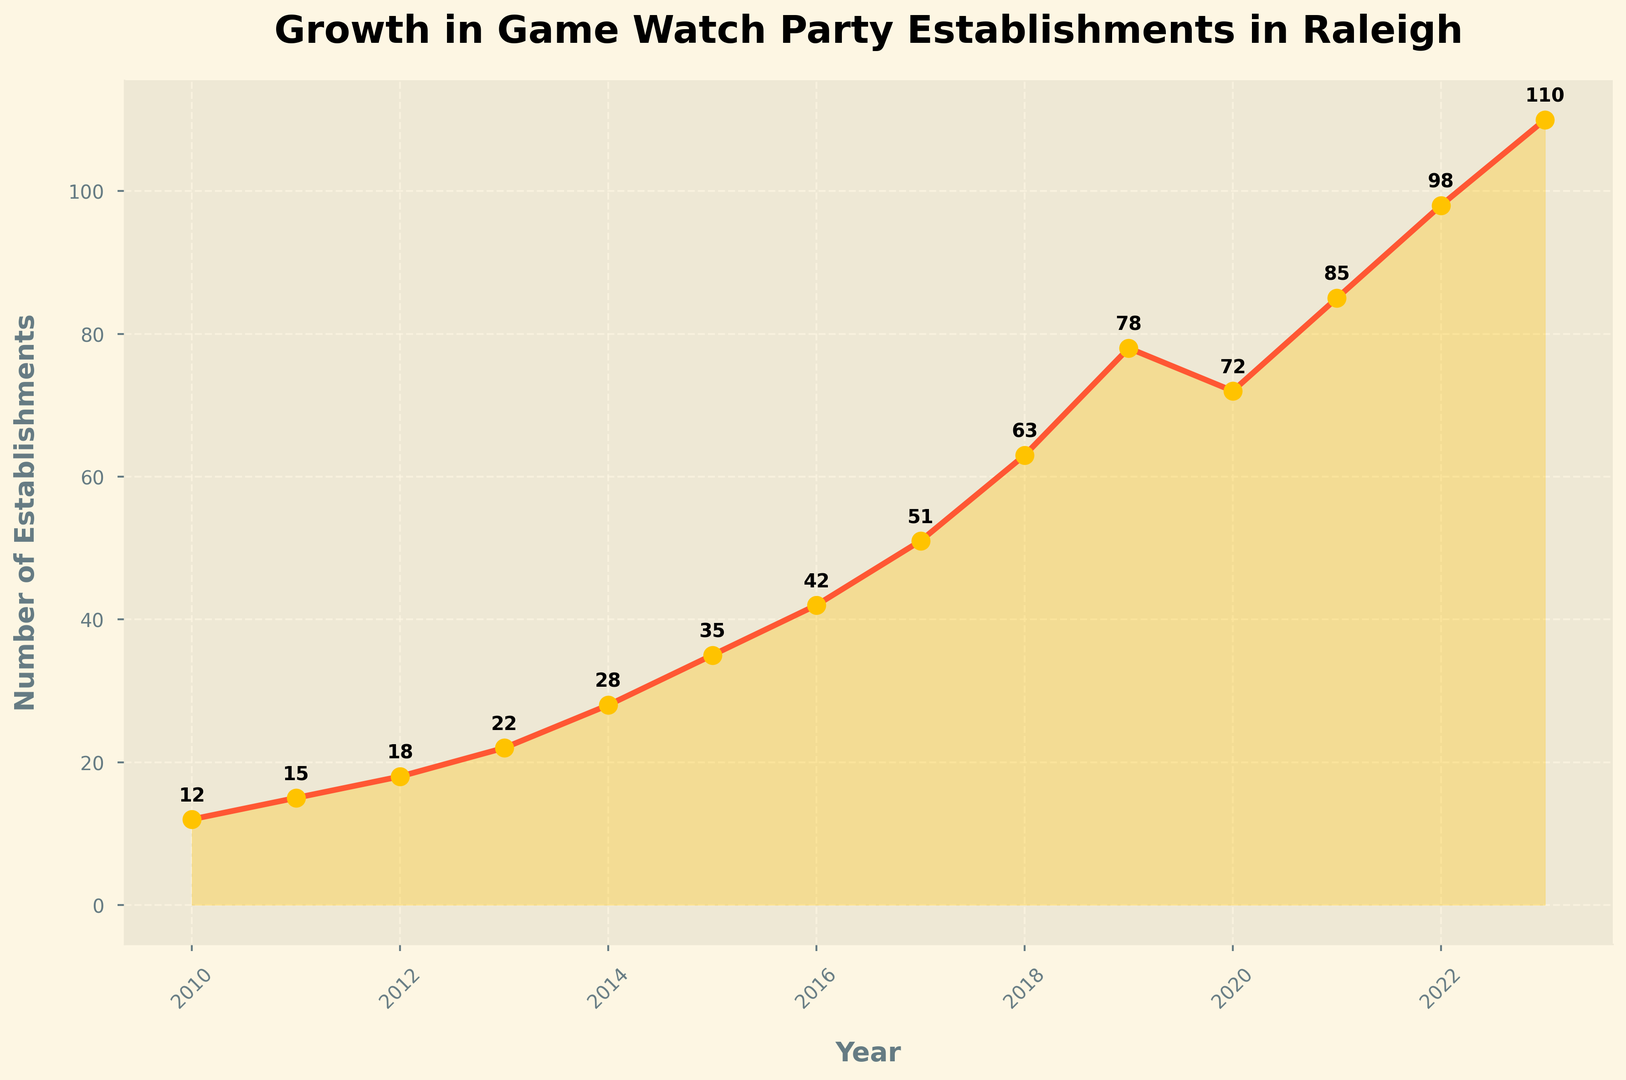What is the total number of establishments in 2015? The data points show the number of establishments in each year. By referring to the figure, find the point for 2015 and read its corresponding value on the y-axis.
Answer: 35 In which year did the number of establishments decrease compared to the previous year? Compare the number of establishments each year and identify any year where the number is lower than the previous year. In this case, between 2019 and 2020, the number decreased from 78 to 72.
Answer: 2020 What is the average number of establishments from 2018 to 2020? Sum the number of establishments from 2018 (63), 2019 (78), and 2020 (72), then divide by the number of years (3). The calculation is (63 + 78 + 72) / 3 = 213 / 3 = 71
Answer: 71 By how much did the number of establishments increase from 2010 to 2023? Subtract the number of establishments in 2010 (12) from the number in 2023 (110). The calculation is 110 - 12 = 98
Answer: 98 Which year saw the highest increase in the number of establishments compared to the previous year? Compare the year-over-year changes in the number of establishments. Between 2018 and 2019, the increase was the highest, going from 63 to 78, which is an increase of 15 establishments.
Answer: 2019 How many years show a number of establishments higher than 50? Look at the number of establishments for each year and count how many years have values greater than 50. From the figure, those years are 2017, 2018, 2019, 2020, 2021, 2022, and 2023. There are 7 years in total.
Answer: 7 What is the average growth in the number of establishments each year from 2011 to 2023? Find the total growth between 2011 (15 establishments) and 2023 (110 establishments). The calculation is 110 - 15 = 95. Then, divide by the number of years from 2011 to 2023, which is 12 years. The average growth per year is 95 / 12 ≈ 7.92
Answer: 7.92 Considering the trend, what is the predicted number of establishments for 2024 if the average growth per year (from 2011 to 2023) continues? Use the average growth of 7.92 establishments per year and add it to the 2023 value (110). The prediction for 2024 is 110 + 7.92 ≈ 118
Answer: 118 